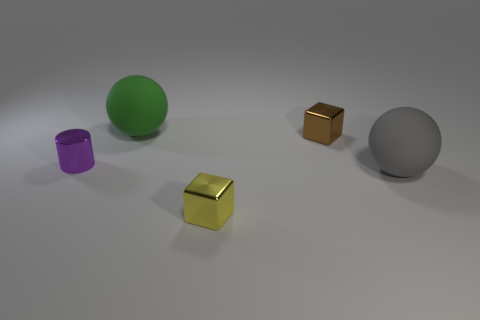Add 3 green rubber cubes. How many objects exist? 8 Subtract all cylinders. How many objects are left? 4 Subtract 1 spheres. How many spheres are left? 1 Subtract all large yellow metal cubes. Subtract all tiny brown metal cubes. How many objects are left? 4 Add 4 brown things. How many brown things are left? 5 Add 2 gray objects. How many gray objects exist? 3 Subtract 1 green balls. How many objects are left? 4 Subtract all purple blocks. Subtract all green balls. How many blocks are left? 2 